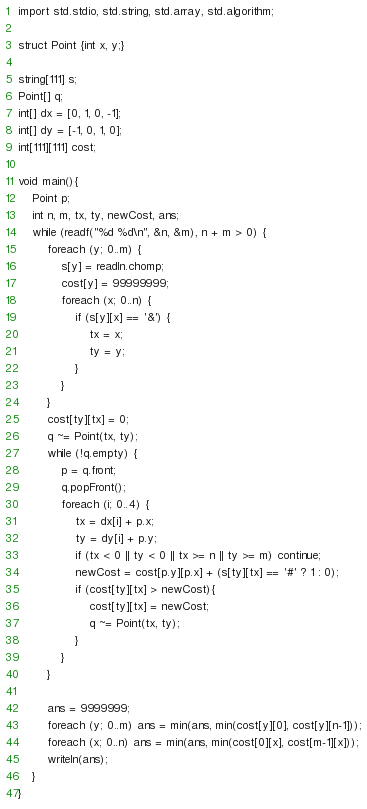Convert code to text. <code><loc_0><loc_0><loc_500><loc_500><_D_>import std.stdio, std.string, std.array, std.algorithm;

struct Point {int x, y;}

string[111] s;
Point[] q;
int[] dx = [0, 1, 0, -1];
int[] dy = [-1, 0, 1, 0];
int[111][111] cost; 

void main(){
	Point p;
	int n, m, tx, ty, newCost, ans;
	while (readf("%d %d\n", &n, &m), n + m > 0) {
		foreach (y; 0..m) {
			s[y] = readln.chomp;
			cost[y] = 99999999;
			foreach (x; 0..n) {
				if (s[y][x] == '&') {
					tx = x;
					ty = y;
				}
			}
		}
		cost[ty][tx] = 0;
		q ~= Point(tx, ty);
		while (!q.empty) {
			p = q.front;
			q.popFront();
			foreach (i; 0..4) {
				tx = dx[i] + p.x;
				ty = dy[i] + p.y;
				if (tx < 0 || ty < 0 || tx >= n || ty >= m) continue;
				newCost = cost[p.y][p.x] + (s[ty][tx] == '#' ? 1 : 0);
				if (cost[ty][tx] > newCost){
					cost[ty][tx] = newCost;
					q ~= Point(tx, ty);
				}
			}
		}

		ans = 9999999;
		foreach (y; 0..m) ans = min(ans, min(cost[y][0], cost[y][n-1]));
		foreach (x; 0..n) ans = min(ans, min(cost[0][x], cost[m-1][x]));
		writeln(ans);
	}
}</code> 